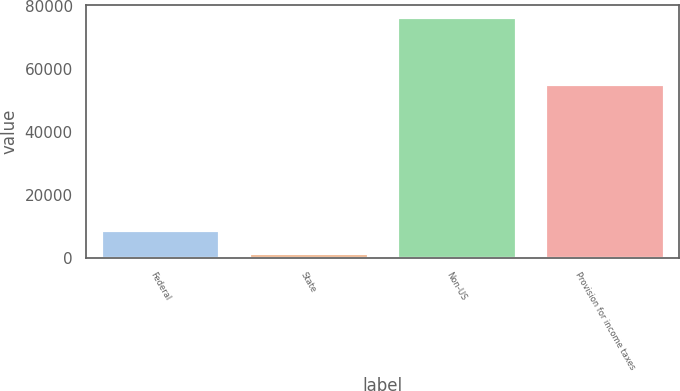Convert chart to OTSL. <chart><loc_0><loc_0><loc_500><loc_500><bar_chart><fcel>Federal<fcel>State<fcel>Non-US<fcel>Provision for income taxes<nl><fcel>8885.3<fcel>1386<fcel>76379<fcel>55236<nl></chart> 